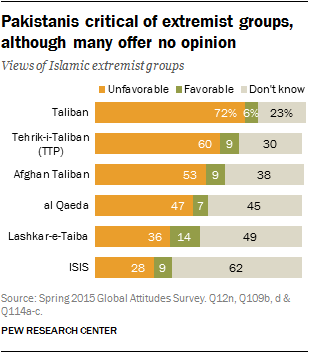Point out several critical features in this image. There are approximately 3 times as many people who are favorable of ISIS compared to the Taliban. According to the poll, only 0.09% of the people surveyed had a favorable view of ISIS. 